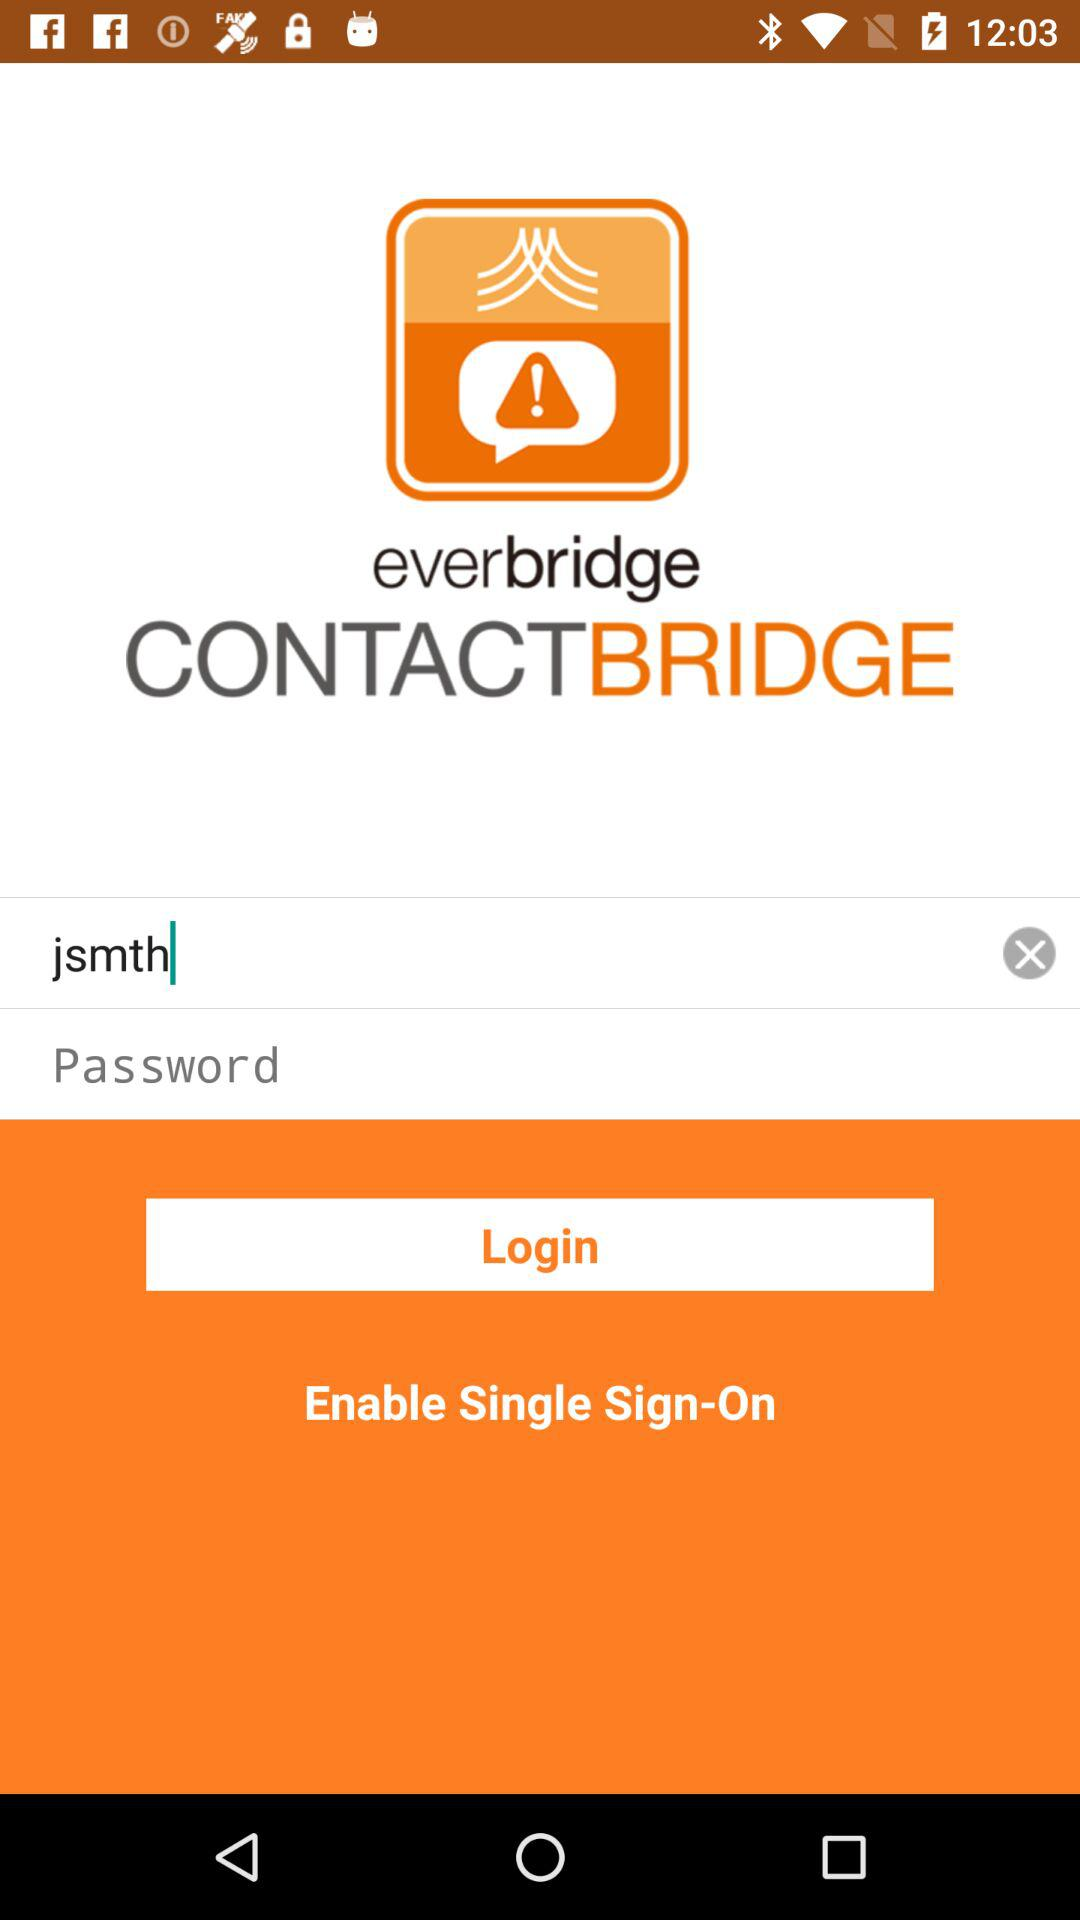What is the app name? The app name is "everbridge CONTACTBRIDGE". 